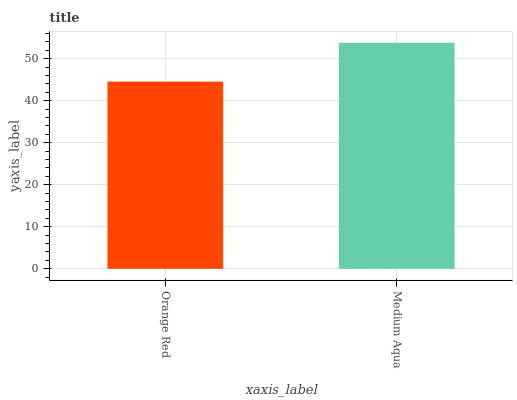Is Medium Aqua the minimum?
Answer yes or no. No. Is Medium Aqua greater than Orange Red?
Answer yes or no. Yes. Is Orange Red less than Medium Aqua?
Answer yes or no. Yes. Is Orange Red greater than Medium Aqua?
Answer yes or no. No. Is Medium Aqua less than Orange Red?
Answer yes or no. No. Is Medium Aqua the high median?
Answer yes or no. Yes. Is Orange Red the low median?
Answer yes or no. Yes. Is Orange Red the high median?
Answer yes or no. No. Is Medium Aqua the low median?
Answer yes or no. No. 